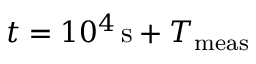Convert formula to latex. <formula><loc_0><loc_0><loc_500><loc_500>t = 1 0 ^ { 4 } \, s + T _ { m e a s }</formula> 